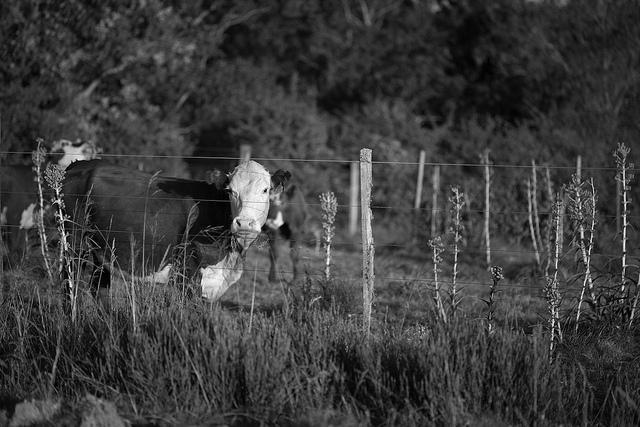How many arched windows are there to the left of the clock tower?
Give a very brief answer. 0. 